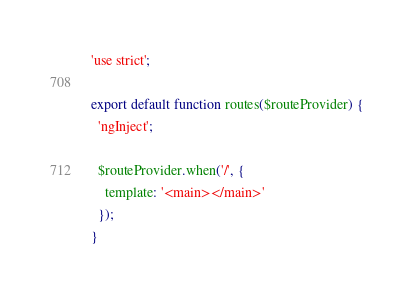Convert code to text. <code><loc_0><loc_0><loc_500><loc_500><_JavaScript_>'use strict';

export default function routes($routeProvider) {
  'ngInject';

  $routeProvider.when('/', {
    template: '<main></main>'
  });
}
</code> 